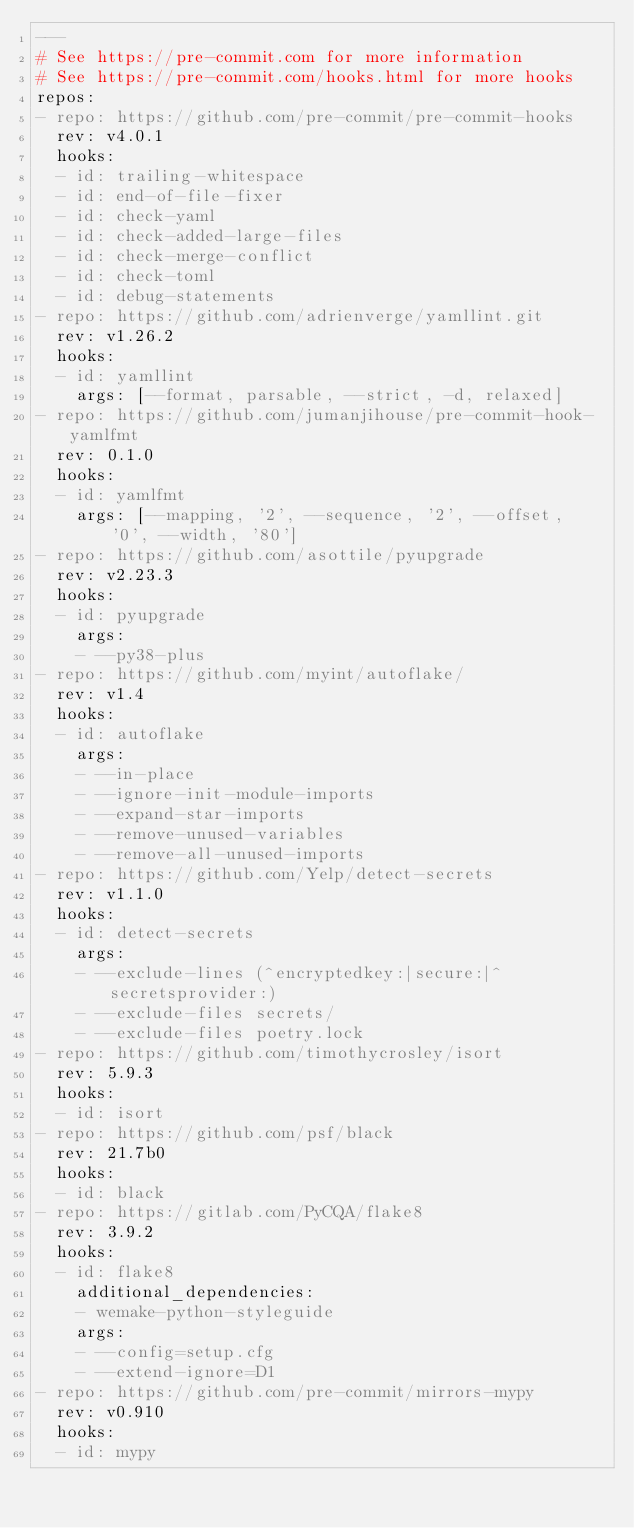<code> <loc_0><loc_0><loc_500><loc_500><_YAML_>---
# See https://pre-commit.com for more information
# See https://pre-commit.com/hooks.html for more hooks
repos:
- repo: https://github.com/pre-commit/pre-commit-hooks
  rev: v4.0.1
  hooks:
  - id: trailing-whitespace
  - id: end-of-file-fixer
  - id: check-yaml
  - id: check-added-large-files
  - id: check-merge-conflict
  - id: check-toml
  - id: debug-statements
- repo: https://github.com/adrienverge/yamllint.git
  rev: v1.26.2
  hooks:
  - id: yamllint
    args: [--format, parsable, --strict, -d, relaxed]
- repo: https://github.com/jumanjihouse/pre-commit-hook-yamlfmt
  rev: 0.1.0
  hooks:
  - id: yamlfmt
    args: [--mapping, '2', --sequence, '2', --offset, '0', --width, '80']
- repo: https://github.com/asottile/pyupgrade
  rev: v2.23.3
  hooks:
  - id: pyupgrade
    args:
    - --py38-plus
- repo: https://github.com/myint/autoflake/
  rev: v1.4
  hooks:
  - id: autoflake
    args:
    - --in-place
    - --ignore-init-module-imports
    - --expand-star-imports
    - --remove-unused-variables
    - --remove-all-unused-imports
- repo: https://github.com/Yelp/detect-secrets
  rev: v1.1.0
  hooks:
  - id: detect-secrets
    args:
    - --exclude-lines (^encryptedkey:|secure:|^secretsprovider:)
    - --exclude-files secrets/
    - --exclude-files poetry.lock
- repo: https://github.com/timothycrosley/isort
  rev: 5.9.3
  hooks:
  - id: isort
- repo: https://github.com/psf/black
  rev: 21.7b0
  hooks:
  - id: black
- repo: https://gitlab.com/PyCQA/flake8
  rev: 3.9.2
  hooks:
  - id: flake8
    additional_dependencies:
    - wemake-python-styleguide
    args:
    - --config=setup.cfg
    - --extend-ignore=D1
- repo: https://github.com/pre-commit/mirrors-mypy
  rev: v0.910
  hooks:
  - id: mypy
</code> 